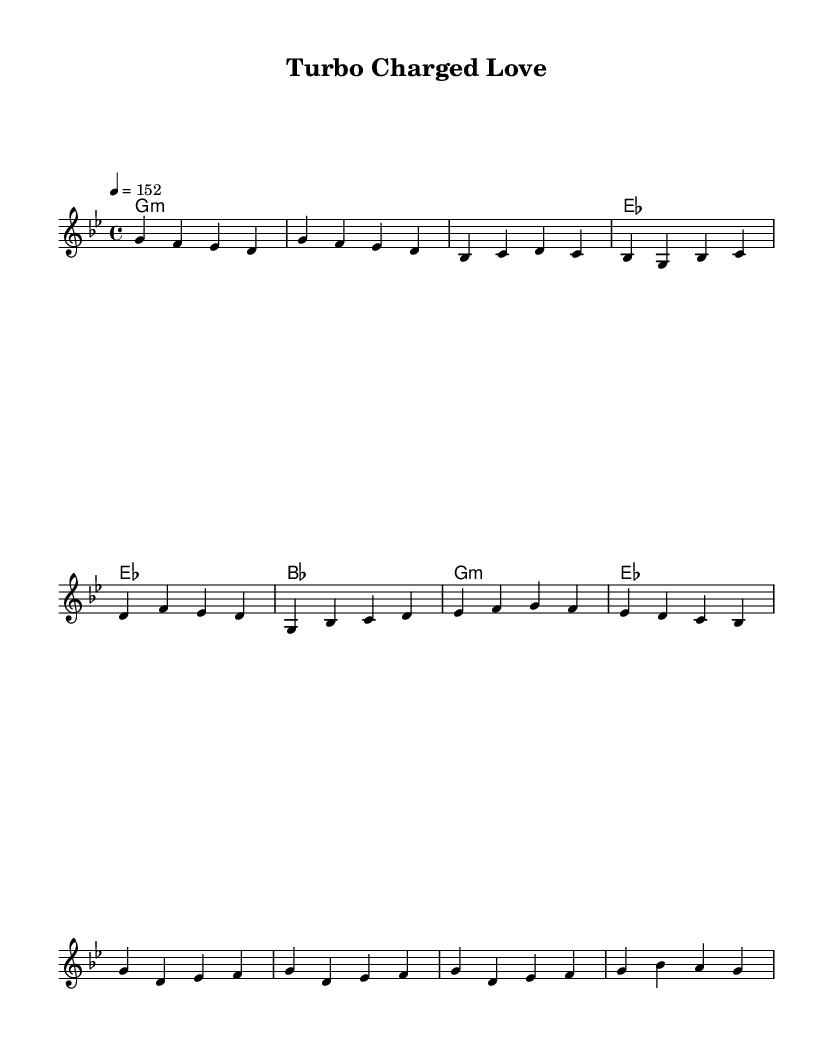What is the key signature of this music? The key signature is G minor, which has two flats: B flat and E flat. You can identify it by looking at the key signature at the beginning of the staff.
Answer: G minor What is the time signature of this music? The time signature is 4/4, which indicates that there are four beats in each measure and the quarter note gets one beat. This is evident from the time signature marking next to the clef.
Answer: 4/4 What is the tempo marking of this music? The tempo marking is 152 beats per minute, indicated by the notation "4 = 152" above the staff. This tells you how fast the piece is played.
Answer: 152 How many measures are in the pre-chorus section? The pre-chorus section consists of four measures, as shown in the notation where it has a specific melodic and harmonic progression. You can count the number of measures from the beginning of the pre-chorus to the end.
Answer: 4 What type of chords are used in the chorus? The chorus features minor chords, specifically G minor and E flat major, which are typically used in K-Pop to create a catchy yet emotional sound. This can be determined by looking at the chord names labeled above the staff.
Answer: Minor chords What rhythmic element reflects a mechanical influence in this K-Pop track? The rhythmic patterns incorporate syncopation and staccato, resembling mechanical sounds; this is characteristic of many K-Pop tracks that integrate engine sounds or pulsating rhythms. This can be analyzed by observing the note lengths and placement in the score.
Answer: Syncopation and staccato What lyrical theme does the title "Turbo Charged Love" suggest for this K-Pop track? The title suggests a high-energy and passionate emotional theme, likely tying into the idea of speed and excitement, which is often present in K-Pop lyrics. This is inferred from the title's energetic terminology.
Answer: Passionate emotional theme 